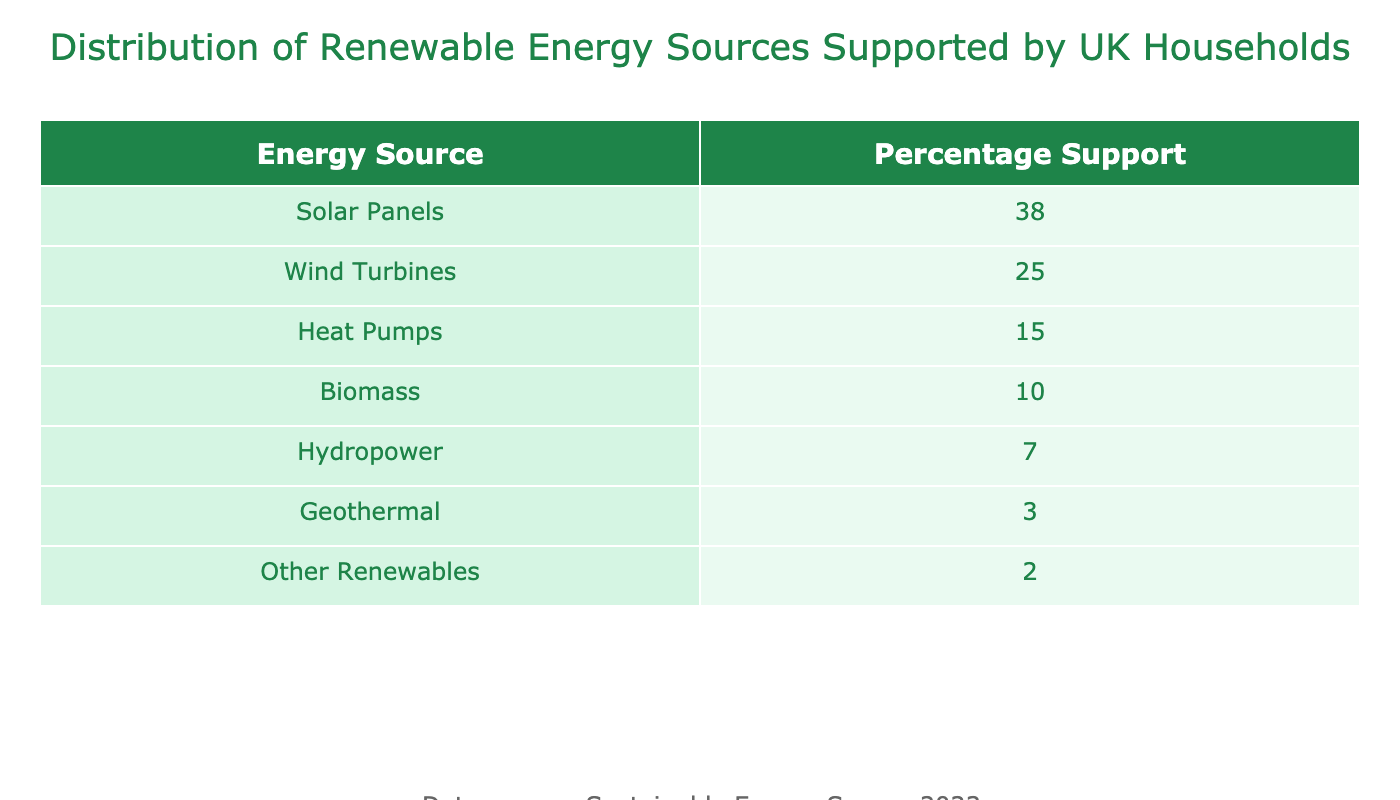What is the percentage support for solar panels? The table clearly shows that solar panels have a percentage support value of 38. This is a direct retrieval from the "Percentage Support" column for the "Solar Panels" row.
Answer: 38 Which renewable energy source has the least support? By examining the "Percentage Support" values in the table, we can see that "Geothermal" has the lowest value at 3. This is also confirmed by comparing the values listed for each energy source.
Answer: Geothermal What is the total percentage support for wind turbines and biomass combined? To calculate the total percentage support for wind turbines and biomass, we add their individual supports: Wind Turbines (25) + Biomass (10) = 35. This sums the values from the respective rows.
Answer: 35 Is the support for hydropower more than that of heat pumps? From the table, Hydropower has a support of 7 while Heat Pumps have a support of 15. Since 7 is less than 15, the statement is false. Thus, we conclude that hydropower does not have more support than heat pumps.
Answer: No What percentage of households support renewable energy sources that are not solar panels or wind turbines? To find this, we need to sum the percentages of the remaining energy sources: Heat Pumps (15) + Biomass (10) + Hydropower (7) + Geothermal (3) + Other Renewables (2) = 37. This involves retrieving and summing the values from the relevant rows.
Answer: 37 Which two energy sources have a combined support of 53%? We can look at the values presented in the table: Solar Panels (38) + Wind Turbines (25) = 63, which is incorrect since this exceeds 53. However, if we try: Biomass (10) + Heat Pumps (15), that totals 25. The required combination appears to be Solar Panels (38) + Biomass (10) = 48, which doesn't work either. Checking any confusion, it seems inaccurate. Thus, no two sources add up to 53%.
Answer: None Are more households supporting wind turbines than geothermal sources? The table shows that wind turbines have a support of 25 while geothermal has a support of 3. Based on this, we can clearly decide that more households support wind turbines compared to geothermal sources.
Answer: Yes What is the difference in percentage support between the highest and lowest supported renewable energy sources? The highest supported energy source is Solar Panels (38), while the lowest is Geothermal (3). Therefore, the difference would be 38 - 3 = 35. This involves subtracting the lowest support value from the highest support value.
Answer: 35 